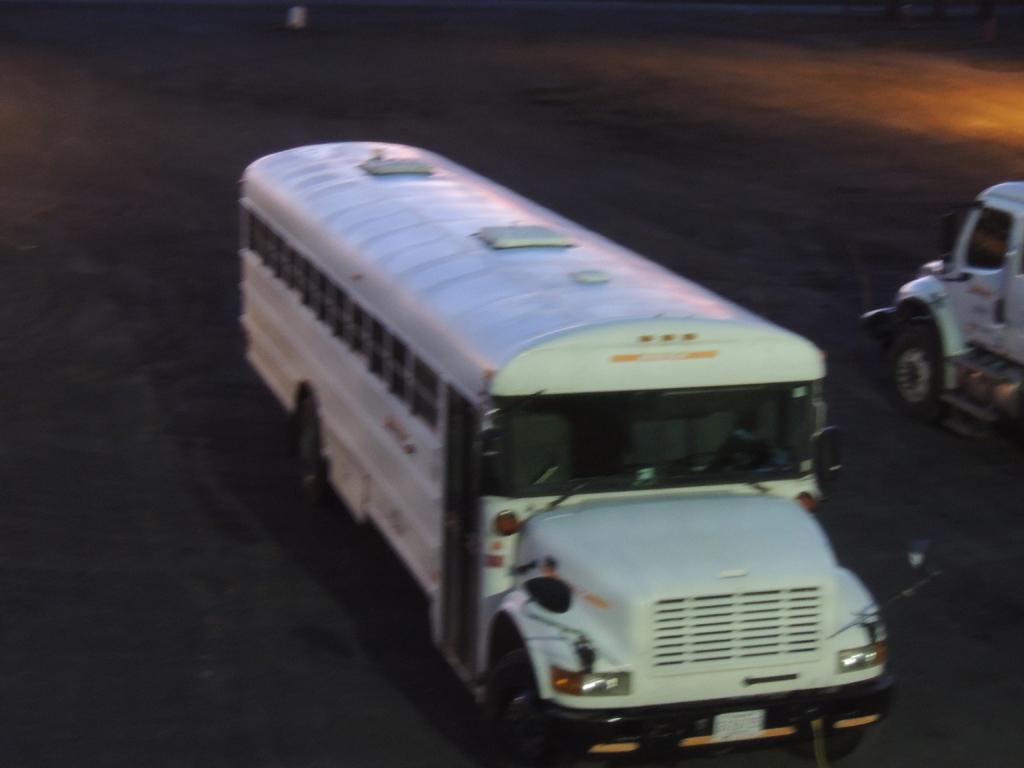What is the main feature of the image? There is a road in the image. What can be seen on the road? There are two vehicles on the road. What color are the vehicles? The vehicles are white in color. What type of protest is happening on the road in the image? There is no protest happening on the road in the image; it only shows two white vehicles. Can you see any pickles on the road in the image? There are no pickles present on the road in the image. 